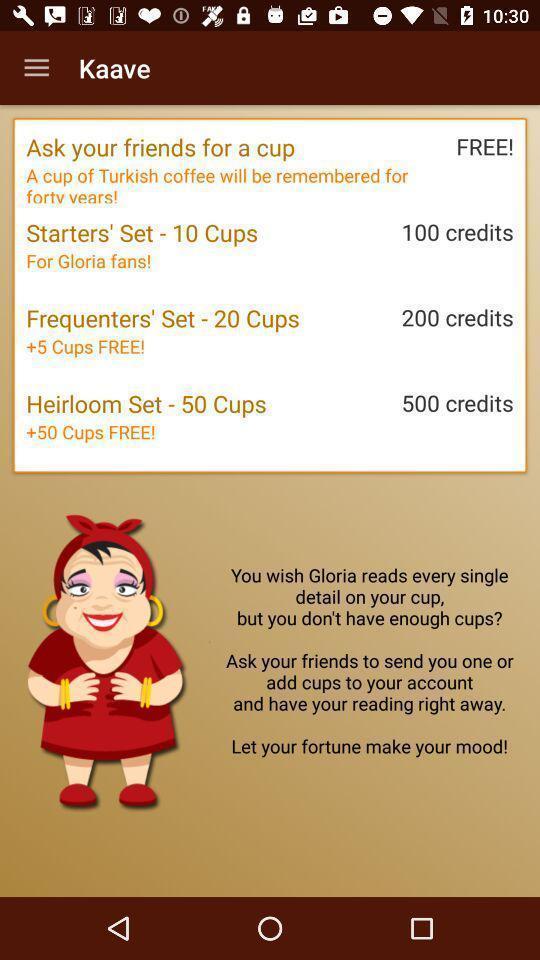What can you discern from this picture? Screen displaying the instructions to earn credits. 